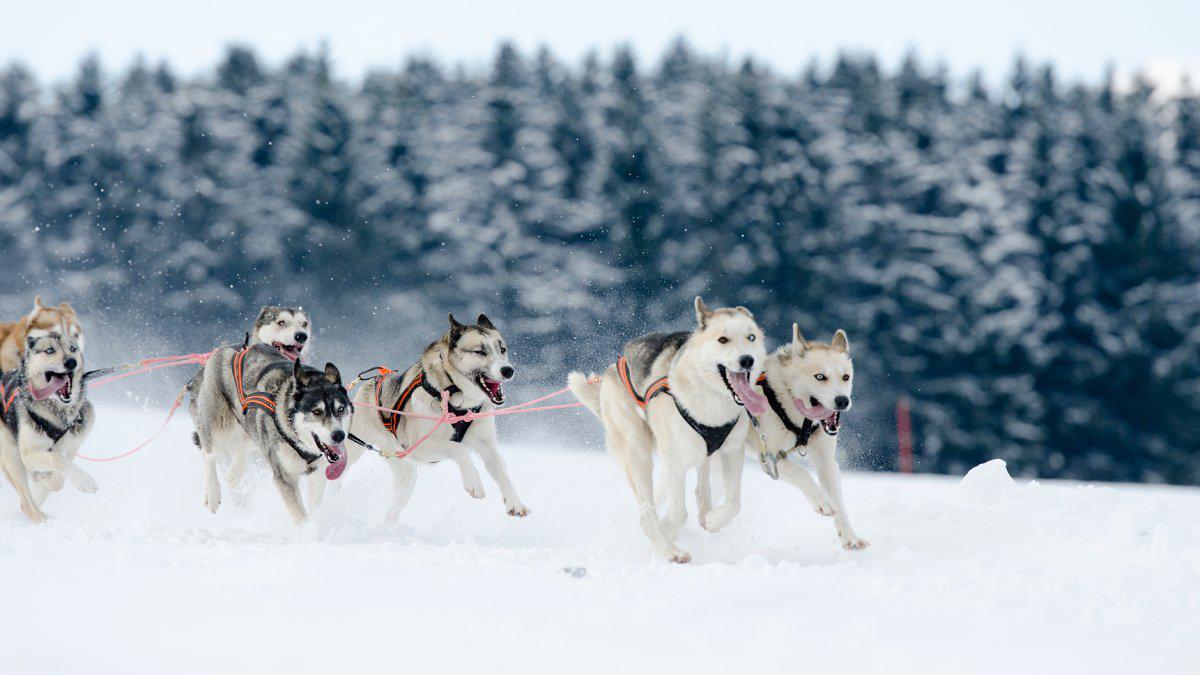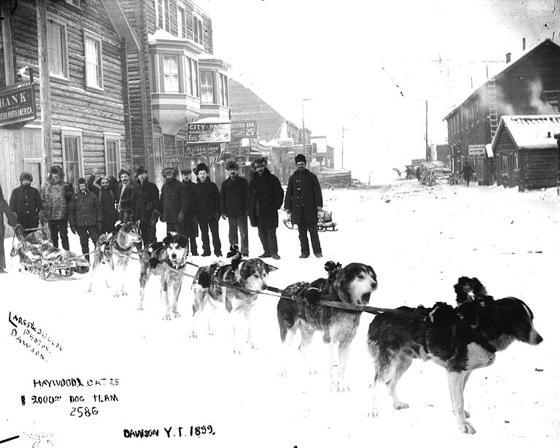The first image is the image on the left, the second image is the image on the right. Examine the images to the left and right. Is the description "None of the lead dogs appear to be mostly white fur." accurate? Answer yes or no. No. The first image is the image on the left, the second image is the image on the right. Assess this claim about the two images: "The left image shows a fur-hooded sled driver standing behind an old-fashioned long wooden sled, and the right image shows a dog sled near buildings.". Correct or not? Answer yes or no. No. 